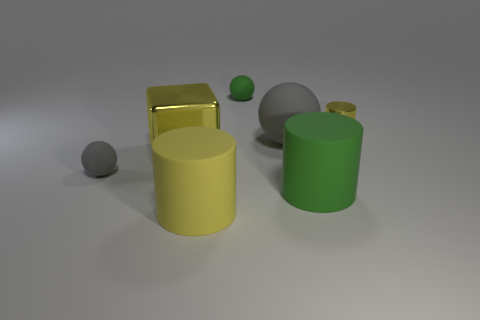What color is the ball that is behind the cylinder behind the large yellow cube?
Your answer should be compact. Green. What is the material of the tiny object that is left of the yellow cylinder that is on the left side of the shiny object on the right side of the small green thing?
Your response must be concise. Rubber. What number of gray matte things have the same size as the metal cube?
Offer a terse response. 1. What is the big thing that is both to the right of the green rubber ball and behind the green cylinder made of?
Provide a short and direct response. Rubber. There is a green rubber sphere; how many matte things are right of it?
Provide a succinct answer. 2. Is the shape of the big gray matte thing the same as the green matte object behind the small yellow shiny object?
Offer a very short reply. Yes. Is there a large green matte thing of the same shape as the big yellow matte thing?
Make the answer very short. Yes. What is the shape of the metallic thing that is on the right side of the green thing that is behind the small gray matte object?
Your answer should be very brief. Cylinder. What is the shape of the big matte object that is to the left of the small green matte thing?
Offer a very short reply. Cylinder. There is a large matte cylinder on the right side of the large gray sphere; does it have the same color as the sphere behind the large gray matte sphere?
Provide a short and direct response. Yes. 